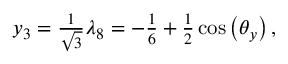<formula> <loc_0><loc_0><loc_500><loc_500>\begin{array} { r } { y _ { 3 } = \frac { 1 } { \sqrt { 3 } } \lambda _ { 8 } = - \frac { 1 } { 6 } + \frac { 1 } { 2 } \cos \left ( \theta _ { y } \right ) , } \end{array}</formula> 